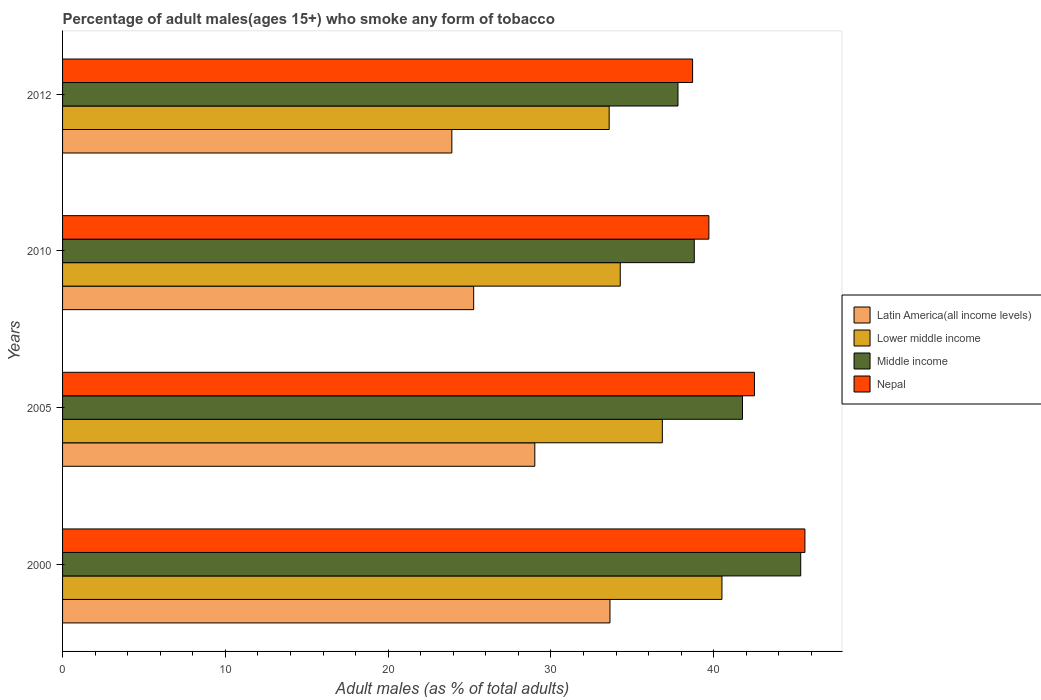How many different coloured bars are there?
Give a very brief answer. 4. How many bars are there on the 4th tick from the top?
Offer a very short reply. 4. What is the percentage of adult males who smoke in Nepal in 2010?
Your answer should be compact. 39.7. Across all years, what is the maximum percentage of adult males who smoke in Nepal?
Your response must be concise. 45.6. Across all years, what is the minimum percentage of adult males who smoke in Latin America(all income levels)?
Provide a succinct answer. 23.91. In which year was the percentage of adult males who smoke in Lower middle income minimum?
Keep it short and to the point. 2012. What is the total percentage of adult males who smoke in Lower middle income in the graph?
Keep it short and to the point. 145.18. What is the difference between the percentage of adult males who smoke in Nepal in 2000 and that in 2012?
Your answer should be compact. 6.9. What is the difference between the percentage of adult males who smoke in Middle income in 2005 and the percentage of adult males who smoke in Lower middle income in 2000?
Your answer should be compact. 1.26. What is the average percentage of adult males who smoke in Latin America(all income levels) per year?
Provide a succinct answer. 27.95. In the year 2010, what is the difference between the percentage of adult males who smoke in Lower middle income and percentage of adult males who smoke in Middle income?
Your answer should be compact. -4.55. In how many years, is the percentage of adult males who smoke in Lower middle income greater than 20 %?
Give a very brief answer. 4. What is the ratio of the percentage of adult males who smoke in Middle income in 2000 to that in 2005?
Your answer should be compact. 1.09. What is the difference between the highest and the second highest percentage of adult males who smoke in Nepal?
Offer a very short reply. 3.1. What is the difference between the highest and the lowest percentage of adult males who smoke in Lower middle income?
Provide a short and direct response. 6.93. What does the 1st bar from the top in 2012 represents?
Your answer should be very brief. Nepal. What does the 1st bar from the bottom in 2010 represents?
Offer a terse response. Latin America(all income levels). Are all the bars in the graph horizontal?
Your answer should be compact. Yes. Are the values on the major ticks of X-axis written in scientific E-notation?
Your answer should be compact. No. Does the graph contain grids?
Provide a short and direct response. No. How many legend labels are there?
Your answer should be compact. 4. What is the title of the graph?
Provide a succinct answer. Percentage of adult males(ages 15+) who smoke any form of tobacco. Does "Iran" appear as one of the legend labels in the graph?
Provide a short and direct response. No. What is the label or title of the X-axis?
Offer a very short reply. Adult males (as % of total adults). What is the label or title of the Y-axis?
Offer a terse response. Years. What is the Adult males (as % of total adults) of Latin America(all income levels) in 2000?
Make the answer very short. 33.62. What is the Adult males (as % of total adults) in Lower middle income in 2000?
Keep it short and to the point. 40.5. What is the Adult males (as % of total adults) of Middle income in 2000?
Your response must be concise. 45.34. What is the Adult males (as % of total adults) in Nepal in 2000?
Your response must be concise. 45.6. What is the Adult males (as % of total adults) of Latin America(all income levels) in 2005?
Your answer should be very brief. 29.01. What is the Adult males (as % of total adults) of Lower middle income in 2005?
Offer a very short reply. 36.84. What is the Adult males (as % of total adults) of Middle income in 2005?
Make the answer very short. 41.77. What is the Adult males (as % of total adults) in Nepal in 2005?
Offer a very short reply. 42.5. What is the Adult males (as % of total adults) of Latin America(all income levels) in 2010?
Give a very brief answer. 25.25. What is the Adult males (as % of total adults) of Lower middle income in 2010?
Your answer should be compact. 34.26. What is the Adult males (as % of total adults) in Middle income in 2010?
Your answer should be compact. 38.8. What is the Adult males (as % of total adults) in Nepal in 2010?
Provide a succinct answer. 39.7. What is the Adult males (as % of total adults) of Latin America(all income levels) in 2012?
Give a very brief answer. 23.91. What is the Adult males (as % of total adults) in Lower middle income in 2012?
Keep it short and to the point. 33.58. What is the Adult males (as % of total adults) of Middle income in 2012?
Your answer should be compact. 37.8. What is the Adult males (as % of total adults) in Nepal in 2012?
Offer a very short reply. 38.7. Across all years, what is the maximum Adult males (as % of total adults) in Latin America(all income levels)?
Give a very brief answer. 33.62. Across all years, what is the maximum Adult males (as % of total adults) in Lower middle income?
Offer a terse response. 40.5. Across all years, what is the maximum Adult males (as % of total adults) of Middle income?
Your response must be concise. 45.34. Across all years, what is the maximum Adult males (as % of total adults) in Nepal?
Offer a terse response. 45.6. Across all years, what is the minimum Adult males (as % of total adults) of Latin America(all income levels)?
Offer a very short reply. 23.91. Across all years, what is the minimum Adult males (as % of total adults) in Lower middle income?
Keep it short and to the point. 33.58. Across all years, what is the minimum Adult males (as % of total adults) in Middle income?
Ensure brevity in your answer.  37.8. Across all years, what is the minimum Adult males (as % of total adults) of Nepal?
Offer a very short reply. 38.7. What is the total Adult males (as % of total adults) of Latin America(all income levels) in the graph?
Keep it short and to the point. 111.8. What is the total Adult males (as % of total adults) of Lower middle income in the graph?
Offer a very short reply. 145.18. What is the total Adult males (as % of total adults) of Middle income in the graph?
Make the answer very short. 163.71. What is the total Adult males (as % of total adults) in Nepal in the graph?
Provide a short and direct response. 166.5. What is the difference between the Adult males (as % of total adults) in Latin America(all income levels) in 2000 and that in 2005?
Offer a terse response. 4.62. What is the difference between the Adult males (as % of total adults) of Lower middle income in 2000 and that in 2005?
Give a very brief answer. 3.66. What is the difference between the Adult males (as % of total adults) of Middle income in 2000 and that in 2005?
Your response must be concise. 3.58. What is the difference between the Adult males (as % of total adults) of Nepal in 2000 and that in 2005?
Provide a succinct answer. 3.1. What is the difference between the Adult males (as % of total adults) of Latin America(all income levels) in 2000 and that in 2010?
Offer a terse response. 8.37. What is the difference between the Adult males (as % of total adults) in Lower middle income in 2000 and that in 2010?
Offer a terse response. 6.25. What is the difference between the Adult males (as % of total adults) in Middle income in 2000 and that in 2010?
Your answer should be very brief. 6.54. What is the difference between the Adult males (as % of total adults) of Latin America(all income levels) in 2000 and that in 2012?
Give a very brief answer. 9.71. What is the difference between the Adult males (as % of total adults) of Lower middle income in 2000 and that in 2012?
Provide a short and direct response. 6.93. What is the difference between the Adult males (as % of total adults) in Middle income in 2000 and that in 2012?
Your answer should be compact. 7.54. What is the difference between the Adult males (as % of total adults) in Latin America(all income levels) in 2005 and that in 2010?
Your answer should be very brief. 3.76. What is the difference between the Adult males (as % of total adults) of Lower middle income in 2005 and that in 2010?
Offer a very short reply. 2.59. What is the difference between the Adult males (as % of total adults) in Middle income in 2005 and that in 2010?
Your answer should be compact. 2.96. What is the difference between the Adult males (as % of total adults) of Latin America(all income levels) in 2005 and that in 2012?
Offer a very short reply. 5.1. What is the difference between the Adult males (as % of total adults) of Lower middle income in 2005 and that in 2012?
Offer a terse response. 3.27. What is the difference between the Adult males (as % of total adults) of Middle income in 2005 and that in 2012?
Ensure brevity in your answer.  3.96. What is the difference between the Adult males (as % of total adults) in Latin America(all income levels) in 2010 and that in 2012?
Your answer should be compact. 1.34. What is the difference between the Adult males (as % of total adults) of Lower middle income in 2010 and that in 2012?
Provide a succinct answer. 0.68. What is the difference between the Adult males (as % of total adults) in Middle income in 2010 and that in 2012?
Give a very brief answer. 1. What is the difference between the Adult males (as % of total adults) of Latin America(all income levels) in 2000 and the Adult males (as % of total adults) of Lower middle income in 2005?
Offer a terse response. -3.22. What is the difference between the Adult males (as % of total adults) in Latin America(all income levels) in 2000 and the Adult males (as % of total adults) in Middle income in 2005?
Ensure brevity in your answer.  -8.14. What is the difference between the Adult males (as % of total adults) in Latin America(all income levels) in 2000 and the Adult males (as % of total adults) in Nepal in 2005?
Provide a succinct answer. -8.88. What is the difference between the Adult males (as % of total adults) in Lower middle income in 2000 and the Adult males (as % of total adults) in Middle income in 2005?
Your answer should be very brief. -1.26. What is the difference between the Adult males (as % of total adults) in Lower middle income in 2000 and the Adult males (as % of total adults) in Nepal in 2005?
Offer a very short reply. -2. What is the difference between the Adult males (as % of total adults) of Middle income in 2000 and the Adult males (as % of total adults) of Nepal in 2005?
Provide a succinct answer. 2.84. What is the difference between the Adult males (as % of total adults) of Latin America(all income levels) in 2000 and the Adult males (as % of total adults) of Lower middle income in 2010?
Your answer should be compact. -0.63. What is the difference between the Adult males (as % of total adults) of Latin America(all income levels) in 2000 and the Adult males (as % of total adults) of Middle income in 2010?
Offer a terse response. -5.18. What is the difference between the Adult males (as % of total adults) in Latin America(all income levels) in 2000 and the Adult males (as % of total adults) in Nepal in 2010?
Your response must be concise. -6.08. What is the difference between the Adult males (as % of total adults) in Lower middle income in 2000 and the Adult males (as % of total adults) in Middle income in 2010?
Offer a terse response. 1.7. What is the difference between the Adult males (as % of total adults) in Lower middle income in 2000 and the Adult males (as % of total adults) in Nepal in 2010?
Your response must be concise. 0.8. What is the difference between the Adult males (as % of total adults) of Middle income in 2000 and the Adult males (as % of total adults) of Nepal in 2010?
Keep it short and to the point. 5.64. What is the difference between the Adult males (as % of total adults) in Latin America(all income levels) in 2000 and the Adult males (as % of total adults) in Lower middle income in 2012?
Provide a succinct answer. 0.05. What is the difference between the Adult males (as % of total adults) in Latin America(all income levels) in 2000 and the Adult males (as % of total adults) in Middle income in 2012?
Make the answer very short. -4.18. What is the difference between the Adult males (as % of total adults) in Latin America(all income levels) in 2000 and the Adult males (as % of total adults) in Nepal in 2012?
Provide a succinct answer. -5.08. What is the difference between the Adult males (as % of total adults) in Lower middle income in 2000 and the Adult males (as % of total adults) in Middle income in 2012?
Make the answer very short. 2.7. What is the difference between the Adult males (as % of total adults) of Lower middle income in 2000 and the Adult males (as % of total adults) of Nepal in 2012?
Ensure brevity in your answer.  1.8. What is the difference between the Adult males (as % of total adults) of Middle income in 2000 and the Adult males (as % of total adults) of Nepal in 2012?
Your answer should be very brief. 6.64. What is the difference between the Adult males (as % of total adults) of Latin America(all income levels) in 2005 and the Adult males (as % of total adults) of Lower middle income in 2010?
Make the answer very short. -5.25. What is the difference between the Adult males (as % of total adults) of Latin America(all income levels) in 2005 and the Adult males (as % of total adults) of Middle income in 2010?
Ensure brevity in your answer.  -9.79. What is the difference between the Adult males (as % of total adults) of Latin America(all income levels) in 2005 and the Adult males (as % of total adults) of Nepal in 2010?
Provide a succinct answer. -10.69. What is the difference between the Adult males (as % of total adults) in Lower middle income in 2005 and the Adult males (as % of total adults) in Middle income in 2010?
Your response must be concise. -1.96. What is the difference between the Adult males (as % of total adults) of Lower middle income in 2005 and the Adult males (as % of total adults) of Nepal in 2010?
Offer a very short reply. -2.86. What is the difference between the Adult males (as % of total adults) in Middle income in 2005 and the Adult males (as % of total adults) in Nepal in 2010?
Keep it short and to the point. 2.07. What is the difference between the Adult males (as % of total adults) of Latin America(all income levels) in 2005 and the Adult males (as % of total adults) of Lower middle income in 2012?
Offer a very short reply. -4.57. What is the difference between the Adult males (as % of total adults) in Latin America(all income levels) in 2005 and the Adult males (as % of total adults) in Middle income in 2012?
Keep it short and to the point. -8.79. What is the difference between the Adult males (as % of total adults) of Latin America(all income levels) in 2005 and the Adult males (as % of total adults) of Nepal in 2012?
Give a very brief answer. -9.69. What is the difference between the Adult males (as % of total adults) in Lower middle income in 2005 and the Adult males (as % of total adults) in Middle income in 2012?
Your answer should be very brief. -0.96. What is the difference between the Adult males (as % of total adults) in Lower middle income in 2005 and the Adult males (as % of total adults) in Nepal in 2012?
Offer a very short reply. -1.86. What is the difference between the Adult males (as % of total adults) in Middle income in 2005 and the Adult males (as % of total adults) in Nepal in 2012?
Give a very brief answer. 3.07. What is the difference between the Adult males (as % of total adults) in Latin America(all income levels) in 2010 and the Adult males (as % of total adults) in Lower middle income in 2012?
Offer a terse response. -8.32. What is the difference between the Adult males (as % of total adults) in Latin America(all income levels) in 2010 and the Adult males (as % of total adults) in Middle income in 2012?
Your answer should be compact. -12.55. What is the difference between the Adult males (as % of total adults) of Latin America(all income levels) in 2010 and the Adult males (as % of total adults) of Nepal in 2012?
Keep it short and to the point. -13.45. What is the difference between the Adult males (as % of total adults) of Lower middle income in 2010 and the Adult males (as % of total adults) of Middle income in 2012?
Keep it short and to the point. -3.55. What is the difference between the Adult males (as % of total adults) in Lower middle income in 2010 and the Adult males (as % of total adults) in Nepal in 2012?
Your answer should be very brief. -4.44. What is the difference between the Adult males (as % of total adults) of Middle income in 2010 and the Adult males (as % of total adults) of Nepal in 2012?
Provide a short and direct response. 0.1. What is the average Adult males (as % of total adults) in Latin America(all income levels) per year?
Provide a succinct answer. 27.95. What is the average Adult males (as % of total adults) in Lower middle income per year?
Keep it short and to the point. 36.29. What is the average Adult males (as % of total adults) in Middle income per year?
Your answer should be very brief. 40.93. What is the average Adult males (as % of total adults) of Nepal per year?
Provide a succinct answer. 41.62. In the year 2000, what is the difference between the Adult males (as % of total adults) of Latin America(all income levels) and Adult males (as % of total adults) of Lower middle income?
Keep it short and to the point. -6.88. In the year 2000, what is the difference between the Adult males (as % of total adults) in Latin America(all income levels) and Adult males (as % of total adults) in Middle income?
Provide a succinct answer. -11.72. In the year 2000, what is the difference between the Adult males (as % of total adults) of Latin America(all income levels) and Adult males (as % of total adults) of Nepal?
Keep it short and to the point. -11.98. In the year 2000, what is the difference between the Adult males (as % of total adults) in Lower middle income and Adult males (as % of total adults) in Middle income?
Ensure brevity in your answer.  -4.84. In the year 2000, what is the difference between the Adult males (as % of total adults) in Lower middle income and Adult males (as % of total adults) in Nepal?
Keep it short and to the point. -5.1. In the year 2000, what is the difference between the Adult males (as % of total adults) in Middle income and Adult males (as % of total adults) in Nepal?
Make the answer very short. -0.26. In the year 2005, what is the difference between the Adult males (as % of total adults) of Latin America(all income levels) and Adult males (as % of total adults) of Lower middle income?
Provide a short and direct response. -7.83. In the year 2005, what is the difference between the Adult males (as % of total adults) in Latin America(all income levels) and Adult males (as % of total adults) in Middle income?
Give a very brief answer. -12.76. In the year 2005, what is the difference between the Adult males (as % of total adults) in Latin America(all income levels) and Adult males (as % of total adults) in Nepal?
Provide a succinct answer. -13.49. In the year 2005, what is the difference between the Adult males (as % of total adults) of Lower middle income and Adult males (as % of total adults) of Middle income?
Your response must be concise. -4.92. In the year 2005, what is the difference between the Adult males (as % of total adults) in Lower middle income and Adult males (as % of total adults) in Nepal?
Your answer should be very brief. -5.66. In the year 2005, what is the difference between the Adult males (as % of total adults) of Middle income and Adult males (as % of total adults) of Nepal?
Offer a terse response. -0.73. In the year 2010, what is the difference between the Adult males (as % of total adults) in Latin America(all income levels) and Adult males (as % of total adults) in Lower middle income?
Your answer should be compact. -9. In the year 2010, what is the difference between the Adult males (as % of total adults) of Latin America(all income levels) and Adult males (as % of total adults) of Middle income?
Provide a short and direct response. -13.55. In the year 2010, what is the difference between the Adult males (as % of total adults) in Latin America(all income levels) and Adult males (as % of total adults) in Nepal?
Provide a succinct answer. -14.45. In the year 2010, what is the difference between the Adult males (as % of total adults) of Lower middle income and Adult males (as % of total adults) of Middle income?
Make the answer very short. -4.55. In the year 2010, what is the difference between the Adult males (as % of total adults) in Lower middle income and Adult males (as % of total adults) in Nepal?
Offer a very short reply. -5.44. In the year 2010, what is the difference between the Adult males (as % of total adults) in Middle income and Adult males (as % of total adults) in Nepal?
Make the answer very short. -0.9. In the year 2012, what is the difference between the Adult males (as % of total adults) of Latin America(all income levels) and Adult males (as % of total adults) of Lower middle income?
Provide a short and direct response. -9.66. In the year 2012, what is the difference between the Adult males (as % of total adults) in Latin America(all income levels) and Adult males (as % of total adults) in Middle income?
Provide a succinct answer. -13.89. In the year 2012, what is the difference between the Adult males (as % of total adults) of Latin America(all income levels) and Adult males (as % of total adults) of Nepal?
Your answer should be compact. -14.79. In the year 2012, what is the difference between the Adult males (as % of total adults) of Lower middle income and Adult males (as % of total adults) of Middle income?
Your response must be concise. -4.23. In the year 2012, what is the difference between the Adult males (as % of total adults) in Lower middle income and Adult males (as % of total adults) in Nepal?
Provide a short and direct response. -5.12. In the year 2012, what is the difference between the Adult males (as % of total adults) of Middle income and Adult males (as % of total adults) of Nepal?
Keep it short and to the point. -0.9. What is the ratio of the Adult males (as % of total adults) in Latin America(all income levels) in 2000 to that in 2005?
Your response must be concise. 1.16. What is the ratio of the Adult males (as % of total adults) in Lower middle income in 2000 to that in 2005?
Ensure brevity in your answer.  1.1. What is the ratio of the Adult males (as % of total adults) of Middle income in 2000 to that in 2005?
Keep it short and to the point. 1.09. What is the ratio of the Adult males (as % of total adults) of Nepal in 2000 to that in 2005?
Offer a very short reply. 1.07. What is the ratio of the Adult males (as % of total adults) in Latin America(all income levels) in 2000 to that in 2010?
Give a very brief answer. 1.33. What is the ratio of the Adult males (as % of total adults) of Lower middle income in 2000 to that in 2010?
Give a very brief answer. 1.18. What is the ratio of the Adult males (as % of total adults) of Middle income in 2000 to that in 2010?
Provide a short and direct response. 1.17. What is the ratio of the Adult males (as % of total adults) of Nepal in 2000 to that in 2010?
Ensure brevity in your answer.  1.15. What is the ratio of the Adult males (as % of total adults) of Latin America(all income levels) in 2000 to that in 2012?
Your answer should be compact. 1.41. What is the ratio of the Adult males (as % of total adults) of Lower middle income in 2000 to that in 2012?
Your answer should be very brief. 1.21. What is the ratio of the Adult males (as % of total adults) of Middle income in 2000 to that in 2012?
Offer a terse response. 1.2. What is the ratio of the Adult males (as % of total adults) of Nepal in 2000 to that in 2012?
Make the answer very short. 1.18. What is the ratio of the Adult males (as % of total adults) of Latin America(all income levels) in 2005 to that in 2010?
Your answer should be very brief. 1.15. What is the ratio of the Adult males (as % of total adults) in Lower middle income in 2005 to that in 2010?
Provide a short and direct response. 1.08. What is the ratio of the Adult males (as % of total adults) in Middle income in 2005 to that in 2010?
Make the answer very short. 1.08. What is the ratio of the Adult males (as % of total adults) of Nepal in 2005 to that in 2010?
Offer a terse response. 1.07. What is the ratio of the Adult males (as % of total adults) of Latin America(all income levels) in 2005 to that in 2012?
Your answer should be compact. 1.21. What is the ratio of the Adult males (as % of total adults) in Lower middle income in 2005 to that in 2012?
Your response must be concise. 1.1. What is the ratio of the Adult males (as % of total adults) of Middle income in 2005 to that in 2012?
Your answer should be compact. 1.1. What is the ratio of the Adult males (as % of total adults) in Nepal in 2005 to that in 2012?
Your answer should be very brief. 1.1. What is the ratio of the Adult males (as % of total adults) of Latin America(all income levels) in 2010 to that in 2012?
Provide a short and direct response. 1.06. What is the ratio of the Adult males (as % of total adults) of Lower middle income in 2010 to that in 2012?
Offer a terse response. 1.02. What is the ratio of the Adult males (as % of total adults) of Middle income in 2010 to that in 2012?
Your answer should be compact. 1.03. What is the ratio of the Adult males (as % of total adults) in Nepal in 2010 to that in 2012?
Your response must be concise. 1.03. What is the difference between the highest and the second highest Adult males (as % of total adults) in Latin America(all income levels)?
Provide a succinct answer. 4.62. What is the difference between the highest and the second highest Adult males (as % of total adults) in Lower middle income?
Give a very brief answer. 3.66. What is the difference between the highest and the second highest Adult males (as % of total adults) in Middle income?
Keep it short and to the point. 3.58. What is the difference between the highest and the second highest Adult males (as % of total adults) in Nepal?
Keep it short and to the point. 3.1. What is the difference between the highest and the lowest Adult males (as % of total adults) in Latin America(all income levels)?
Provide a succinct answer. 9.71. What is the difference between the highest and the lowest Adult males (as % of total adults) of Lower middle income?
Offer a very short reply. 6.93. What is the difference between the highest and the lowest Adult males (as % of total adults) of Middle income?
Make the answer very short. 7.54. 